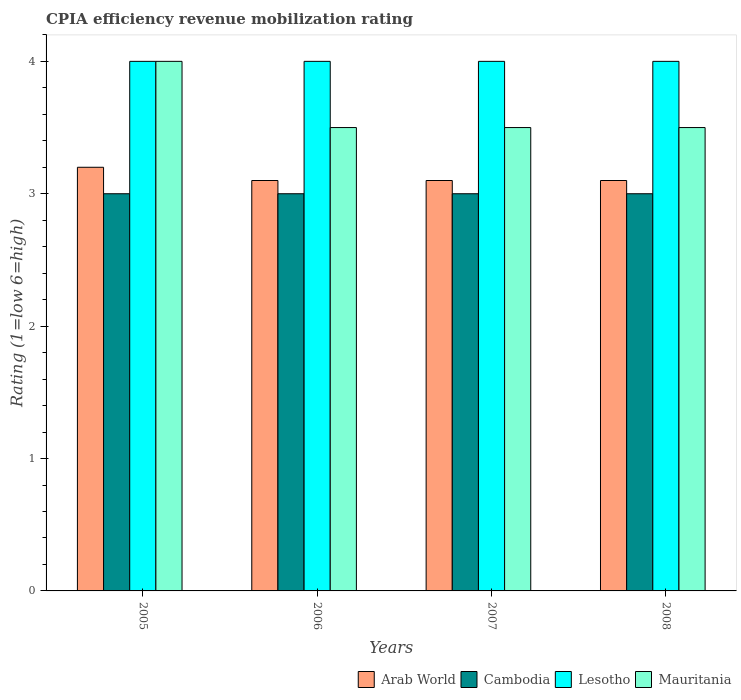How many bars are there on the 3rd tick from the left?
Provide a short and direct response. 4. How many bars are there on the 1st tick from the right?
Provide a succinct answer. 4. What is the label of the 4th group of bars from the left?
Give a very brief answer. 2008. Across all years, what is the minimum CPIA rating in Lesotho?
Make the answer very short. 4. In which year was the CPIA rating in Lesotho maximum?
Your response must be concise. 2005. What is the total CPIA rating in Lesotho in the graph?
Give a very brief answer. 16. What is the difference between the CPIA rating in Mauritania in 2006 and that in 2007?
Give a very brief answer. 0. What is the average CPIA rating in Cambodia per year?
Keep it short and to the point. 3. In the year 2008, what is the difference between the CPIA rating in Lesotho and CPIA rating in Cambodia?
Ensure brevity in your answer.  1. What is the ratio of the CPIA rating in Lesotho in 2005 to that in 2006?
Give a very brief answer. 1. Is the CPIA rating in Mauritania in 2005 less than that in 2006?
Offer a very short reply. No. What does the 3rd bar from the left in 2007 represents?
Make the answer very short. Lesotho. What does the 1st bar from the right in 2007 represents?
Offer a terse response. Mauritania. Is it the case that in every year, the sum of the CPIA rating in Arab World and CPIA rating in Mauritania is greater than the CPIA rating in Lesotho?
Offer a terse response. Yes. How many years are there in the graph?
Your answer should be very brief. 4. Are the values on the major ticks of Y-axis written in scientific E-notation?
Ensure brevity in your answer.  No. Where does the legend appear in the graph?
Ensure brevity in your answer.  Bottom right. How many legend labels are there?
Offer a very short reply. 4. What is the title of the graph?
Ensure brevity in your answer.  CPIA efficiency revenue mobilization rating. What is the Rating (1=low 6=high) of Cambodia in 2005?
Offer a terse response. 3. What is the Rating (1=low 6=high) in Lesotho in 2005?
Provide a succinct answer. 4. What is the Rating (1=low 6=high) in Mauritania in 2005?
Ensure brevity in your answer.  4. What is the Rating (1=low 6=high) of Arab World in 2006?
Keep it short and to the point. 3.1. What is the Rating (1=low 6=high) of Cambodia in 2006?
Provide a short and direct response. 3. What is the Rating (1=low 6=high) of Lesotho in 2006?
Keep it short and to the point. 4. What is the Rating (1=low 6=high) in Mauritania in 2006?
Ensure brevity in your answer.  3.5. What is the Rating (1=low 6=high) of Cambodia in 2007?
Your response must be concise. 3. What is the Rating (1=low 6=high) in Lesotho in 2007?
Make the answer very short. 4. What is the Rating (1=low 6=high) of Mauritania in 2007?
Your answer should be compact. 3.5. What is the Rating (1=low 6=high) of Lesotho in 2008?
Your response must be concise. 4. Across all years, what is the maximum Rating (1=low 6=high) in Cambodia?
Make the answer very short. 3. Across all years, what is the maximum Rating (1=low 6=high) in Mauritania?
Give a very brief answer. 4. Across all years, what is the minimum Rating (1=low 6=high) of Cambodia?
Offer a terse response. 3. Across all years, what is the minimum Rating (1=low 6=high) in Lesotho?
Your answer should be compact. 4. Across all years, what is the minimum Rating (1=low 6=high) in Mauritania?
Keep it short and to the point. 3.5. What is the total Rating (1=low 6=high) of Arab World in the graph?
Make the answer very short. 12.5. What is the total Rating (1=low 6=high) of Lesotho in the graph?
Your response must be concise. 16. What is the difference between the Rating (1=low 6=high) in Arab World in 2005 and that in 2006?
Your answer should be very brief. 0.1. What is the difference between the Rating (1=low 6=high) in Cambodia in 2005 and that in 2006?
Offer a terse response. 0. What is the difference between the Rating (1=low 6=high) in Mauritania in 2005 and that in 2008?
Your answer should be very brief. 0.5. What is the difference between the Rating (1=low 6=high) of Arab World in 2006 and that in 2007?
Offer a terse response. 0. What is the difference between the Rating (1=low 6=high) of Cambodia in 2006 and that in 2007?
Ensure brevity in your answer.  0. What is the difference between the Rating (1=low 6=high) of Mauritania in 2006 and that in 2007?
Your answer should be compact. 0. What is the difference between the Rating (1=low 6=high) of Arab World in 2006 and that in 2008?
Provide a short and direct response. 0. What is the difference between the Rating (1=low 6=high) in Cambodia in 2006 and that in 2008?
Offer a very short reply. 0. What is the difference between the Rating (1=low 6=high) in Lesotho in 2006 and that in 2008?
Your answer should be very brief. 0. What is the difference between the Rating (1=low 6=high) of Mauritania in 2006 and that in 2008?
Ensure brevity in your answer.  0. What is the difference between the Rating (1=low 6=high) in Arab World in 2007 and that in 2008?
Ensure brevity in your answer.  0. What is the difference between the Rating (1=low 6=high) in Cambodia in 2007 and that in 2008?
Your response must be concise. 0. What is the difference between the Rating (1=low 6=high) of Lesotho in 2007 and that in 2008?
Keep it short and to the point. 0. What is the difference between the Rating (1=low 6=high) of Mauritania in 2007 and that in 2008?
Your answer should be compact. 0. What is the difference between the Rating (1=low 6=high) in Arab World in 2005 and the Rating (1=low 6=high) in Cambodia in 2006?
Your answer should be very brief. 0.2. What is the difference between the Rating (1=low 6=high) in Arab World in 2005 and the Rating (1=low 6=high) in Lesotho in 2006?
Offer a very short reply. -0.8. What is the difference between the Rating (1=low 6=high) in Cambodia in 2005 and the Rating (1=low 6=high) in Lesotho in 2006?
Provide a short and direct response. -1. What is the difference between the Rating (1=low 6=high) of Cambodia in 2005 and the Rating (1=low 6=high) of Mauritania in 2006?
Keep it short and to the point. -0.5. What is the difference between the Rating (1=low 6=high) of Arab World in 2005 and the Rating (1=low 6=high) of Cambodia in 2007?
Your answer should be compact. 0.2. What is the difference between the Rating (1=low 6=high) of Cambodia in 2005 and the Rating (1=low 6=high) of Lesotho in 2007?
Provide a succinct answer. -1. What is the difference between the Rating (1=low 6=high) of Cambodia in 2005 and the Rating (1=low 6=high) of Mauritania in 2007?
Make the answer very short. -0.5. What is the difference between the Rating (1=low 6=high) in Lesotho in 2005 and the Rating (1=low 6=high) in Mauritania in 2007?
Provide a short and direct response. 0.5. What is the difference between the Rating (1=low 6=high) in Arab World in 2005 and the Rating (1=low 6=high) in Lesotho in 2008?
Provide a succinct answer. -0.8. What is the difference between the Rating (1=low 6=high) of Cambodia in 2005 and the Rating (1=low 6=high) of Lesotho in 2008?
Make the answer very short. -1. What is the difference between the Rating (1=low 6=high) in Lesotho in 2005 and the Rating (1=low 6=high) in Mauritania in 2008?
Your answer should be compact. 0.5. What is the difference between the Rating (1=low 6=high) of Arab World in 2006 and the Rating (1=low 6=high) of Cambodia in 2007?
Offer a very short reply. 0.1. What is the difference between the Rating (1=low 6=high) of Arab World in 2006 and the Rating (1=low 6=high) of Mauritania in 2007?
Offer a very short reply. -0.4. What is the difference between the Rating (1=low 6=high) of Cambodia in 2006 and the Rating (1=low 6=high) of Lesotho in 2007?
Your answer should be very brief. -1. What is the difference between the Rating (1=low 6=high) of Cambodia in 2006 and the Rating (1=low 6=high) of Mauritania in 2007?
Your answer should be very brief. -0.5. What is the difference between the Rating (1=low 6=high) in Lesotho in 2006 and the Rating (1=low 6=high) in Mauritania in 2007?
Provide a short and direct response. 0.5. What is the difference between the Rating (1=low 6=high) in Arab World in 2006 and the Rating (1=low 6=high) in Cambodia in 2008?
Make the answer very short. 0.1. What is the difference between the Rating (1=low 6=high) of Cambodia in 2006 and the Rating (1=low 6=high) of Lesotho in 2008?
Offer a very short reply. -1. What is the difference between the Rating (1=low 6=high) of Cambodia in 2006 and the Rating (1=low 6=high) of Mauritania in 2008?
Your response must be concise. -0.5. What is the difference between the Rating (1=low 6=high) in Arab World in 2007 and the Rating (1=low 6=high) in Lesotho in 2008?
Make the answer very short. -0.9. What is the difference between the Rating (1=low 6=high) in Cambodia in 2007 and the Rating (1=low 6=high) in Lesotho in 2008?
Your answer should be compact. -1. What is the difference between the Rating (1=low 6=high) of Cambodia in 2007 and the Rating (1=low 6=high) of Mauritania in 2008?
Offer a very short reply. -0.5. What is the average Rating (1=low 6=high) of Arab World per year?
Provide a succinct answer. 3.12. What is the average Rating (1=low 6=high) in Lesotho per year?
Keep it short and to the point. 4. What is the average Rating (1=low 6=high) in Mauritania per year?
Give a very brief answer. 3.62. In the year 2005, what is the difference between the Rating (1=low 6=high) in Arab World and Rating (1=low 6=high) in Lesotho?
Your answer should be very brief. -0.8. In the year 2005, what is the difference between the Rating (1=low 6=high) of Cambodia and Rating (1=low 6=high) of Lesotho?
Your answer should be compact. -1. In the year 2006, what is the difference between the Rating (1=low 6=high) of Arab World and Rating (1=low 6=high) of Mauritania?
Give a very brief answer. -0.4. In the year 2006, what is the difference between the Rating (1=low 6=high) in Cambodia and Rating (1=low 6=high) in Lesotho?
Your answer should be very brief. -1. In the year 2006, what is the difference between the Rating (1=low 6=high) of Cambodia and Rating (1=low 6=high) of Mauritania?
Your response must be concise. -0.5. In the year 2006, what is the difference between the Rating (1=low 6=high) of Lesotho and Rating (1=low 6=high) of Mauritania?
Offer a terse response. 0.5. In the year 2007, what is the difference between the Rating (1=low 6=high) of Arab World and Rating (1=low 6=high) of Cambodia?
Your answer should be very brief. 0.1. In the year 2007, what is the difference between the Rating (1=low 6=high) of Arab World and Rating (1=low 6=high) of Mauritania?
Keep it short and to the point. -0.4. In the year 2007, what is the difference between the Rating (1=low 6=high) of Cambodia and Rating (1=low 6=high) of Lesotho?
Provide a succinct answer. -1. In the year 2007, what is the difference between the Rating (1=low 6=high) of Cambodia and Rating (1=low 6=high) of Mauritania?
Your answer should be very brief. -0.5. In the year 2008, what is the difference between the Rating (1=low 6=high) in Arab World and Rating (1=low 6=high) in Cambodia?
Provide a succinct answer. 0.1. In the year 2008, what is the difference between the Rating (1=low 6=high) of Cambodia and Rating (1=low 6=high) of Mauritania?
Keep it short and to the point. -0.5. What is the ratio of the Rating (1=low 6=high) of Arab World in 2005 to that in 2006?
Make the answer very short. 1.03. What is the ratio of the Rating (1=low 6=high) in Mauritania in 2005 to that in 2006?
Provide a succinct answer. 1.14. What is the ratio of the Rating (1=low 6=high) in Arab World in 2005 to that in 2007?
Your response must be concise. 1.03. What is the ratio of the Rating (1=low 6=high) in Mauritania in 2005 to that in 2007?
Keep it short and to the point. 1.14. What is the ratio of the Rating (1=low 6=high) of Arab World in 2005 to that in 2008?
Ensure brevity in your answer.  1.03. What is the ratio of the Rating (1=low 6=high) in Cambodia in 2005 to that in 2008?
Offer a very short reply. 1. What is the ratio of the Rating (1=low 6=high) of Lesotho in 2006 to that in 2007?
Offer a terse response. 1. What is the ratio of the Rating (1=low 6=high) in Mauritania in 2006 to that in 2007?
Ensure brevity in your answer.  1. What is the ratio of the Rating (1=low 6=high) in Arab World in 2006 to that in 2008?
Your response must be concise. 1. What is the ratio of the Rating (1=low 6=high) of Cambodia in 2006 to that in 2008?
Your response must be concise. 1. What is the ratio of the Rating (1=low 6=high) in Cambodia in 2007 to that in 2008?
Provide a short and direct response. 1. What is the ratio of the Rating (1=low 6=high) of Mauritania in 2007 to that in 2008?
Offer a terse response. 1. What is the difference between the highest and the second highest Rating (1=low 6=high) of Cambodia?
Offer a terse response. 0. What is the difference between the highest and the second highest Rating (1=low 6=high) of Mauritania?
Ensure brevity in your answer.  0.5. What is the difference between the highest and the lowest Rating (1=low 6=high) of Arab World?
Your response must be concise. 0.1. What is the difference between the highest and the lowest Rating (1=low 6=high) of Lesotho?
Ensure brevity in your answer.  0. 